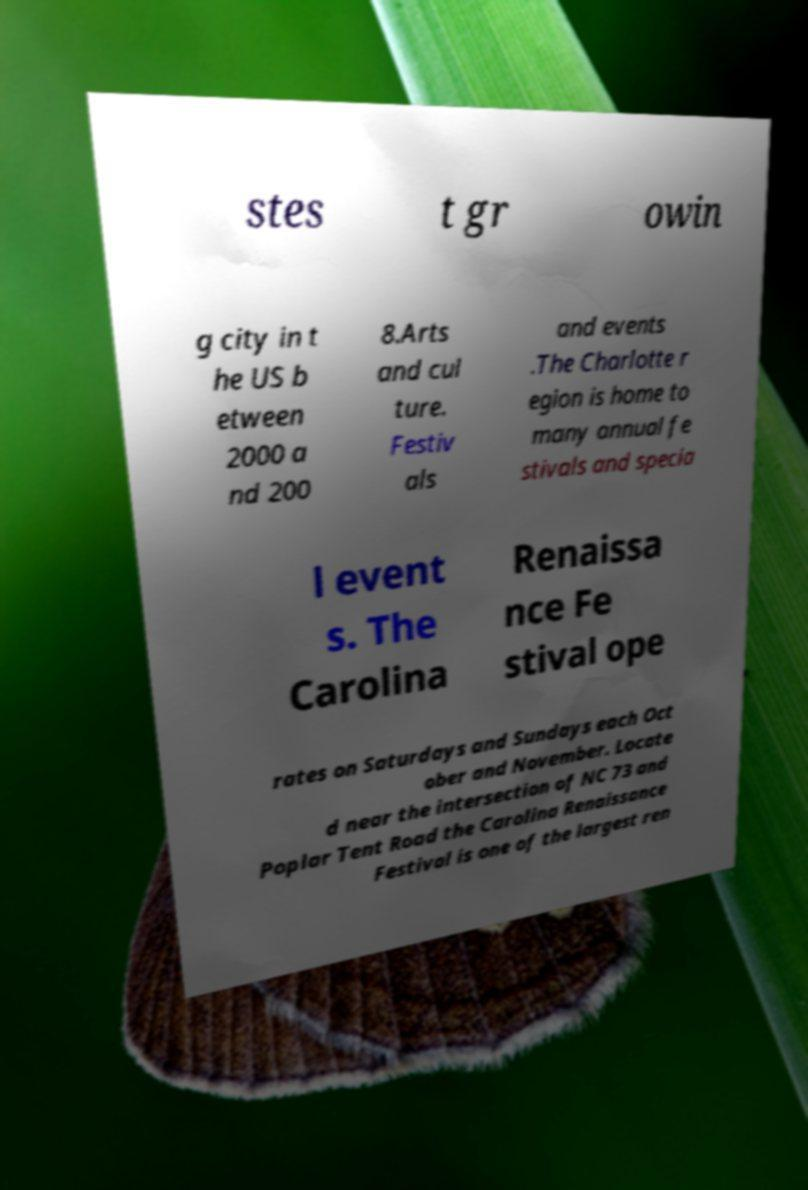I need the written content from this picture converted into text. Can you do that? stes t gr owin g city in t he US b etween 2000 a nd 200 8.Arts and cul ture. Festiv als and events .The Charlotte r egion is home to many annual fe stivals and specia l event s. The Carolina Renaissa nce Fe stival ope rates on Saturdays and Sundays each Oct ober and November. Locate d near the intersection of NC 73 and Poplar Tent Road the Carolina Renaissance Festival is one of the largest ren 